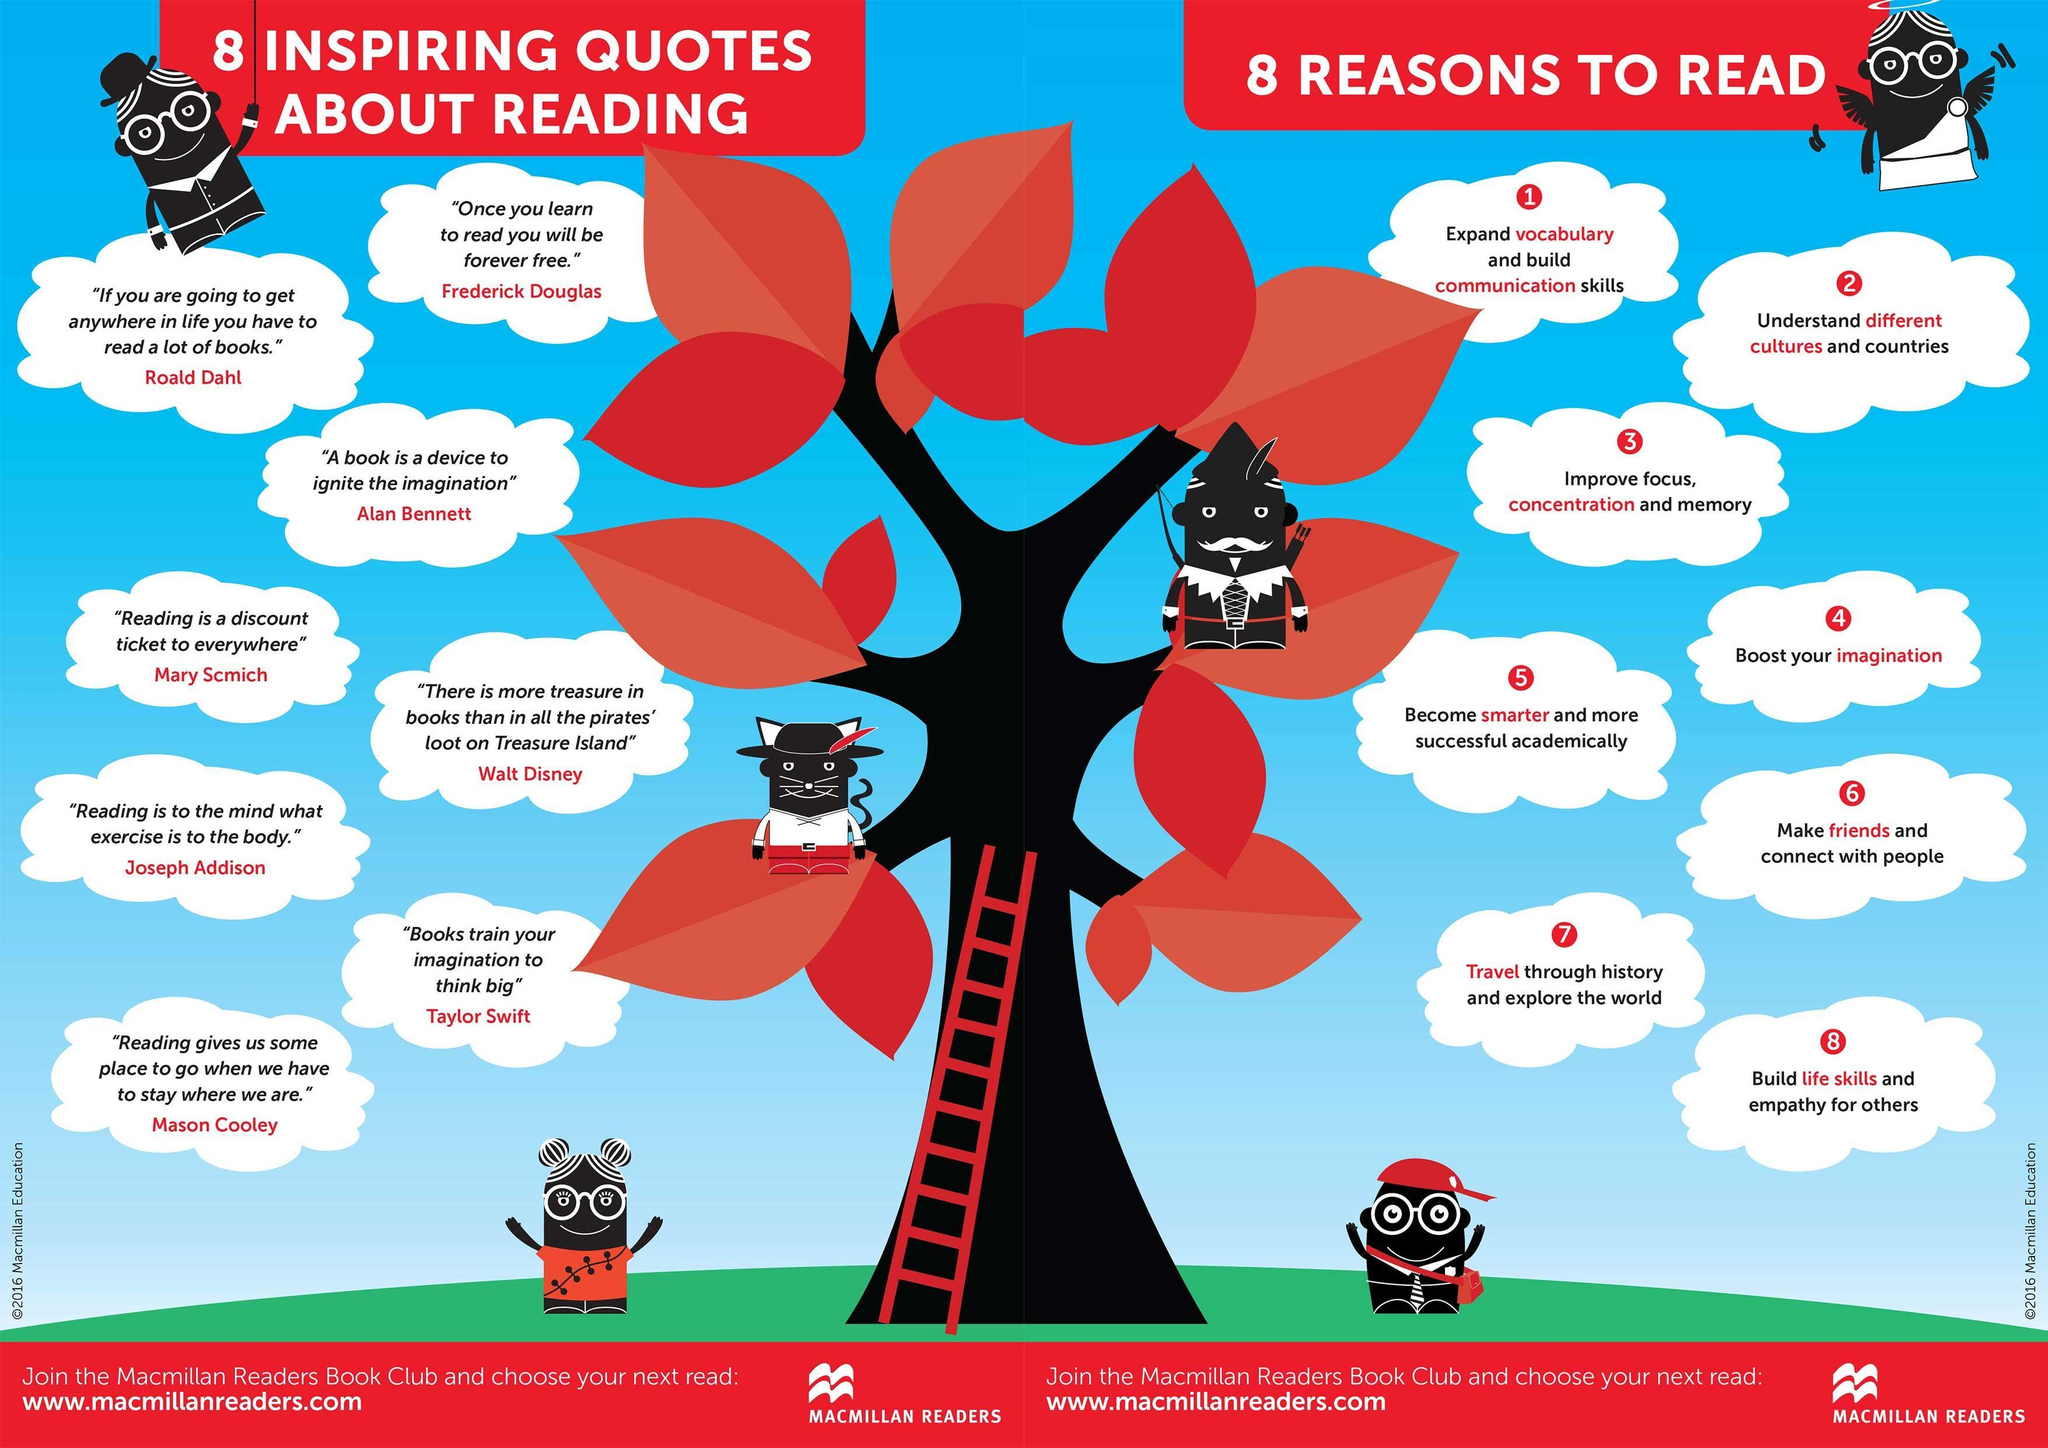Who quoted the words 'Reading is a discount ticket to everywhere'?
Answer the question with a short phrase. Mary Scmich 